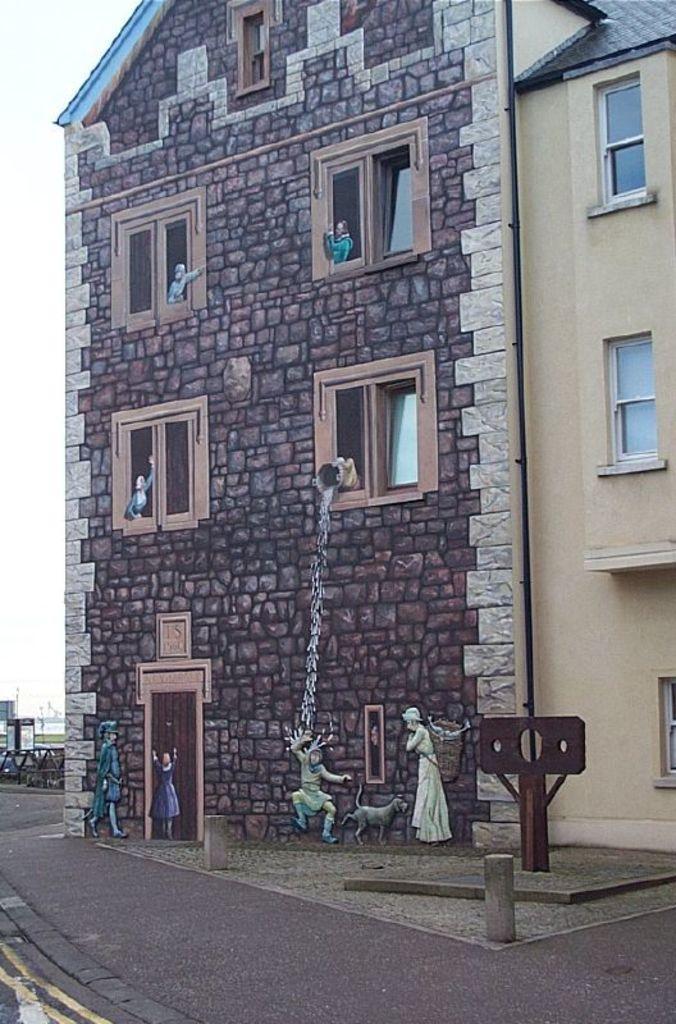How would you summarize this image in a sentence or two? At the bottom of the picture, we see the road. In the middle, we see a board in brown color and we even see the cement blocks. On the right side, we see a building. Beside that, we see a building which is made up of cobblestones. We see the windows and the statues. On the left side, we see the poles, boards and the buildings. In the left top, we see the sky. 